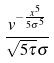Convert formula to latex. <formula><loc_0><loc_0><loc_500><loc_500>\frac { v ^ { - \frac { x ^ { 5 } } { 5 \sigma ^ { 5 } } } } { \sqrt { 5 \tau } \sigma }</formula> 